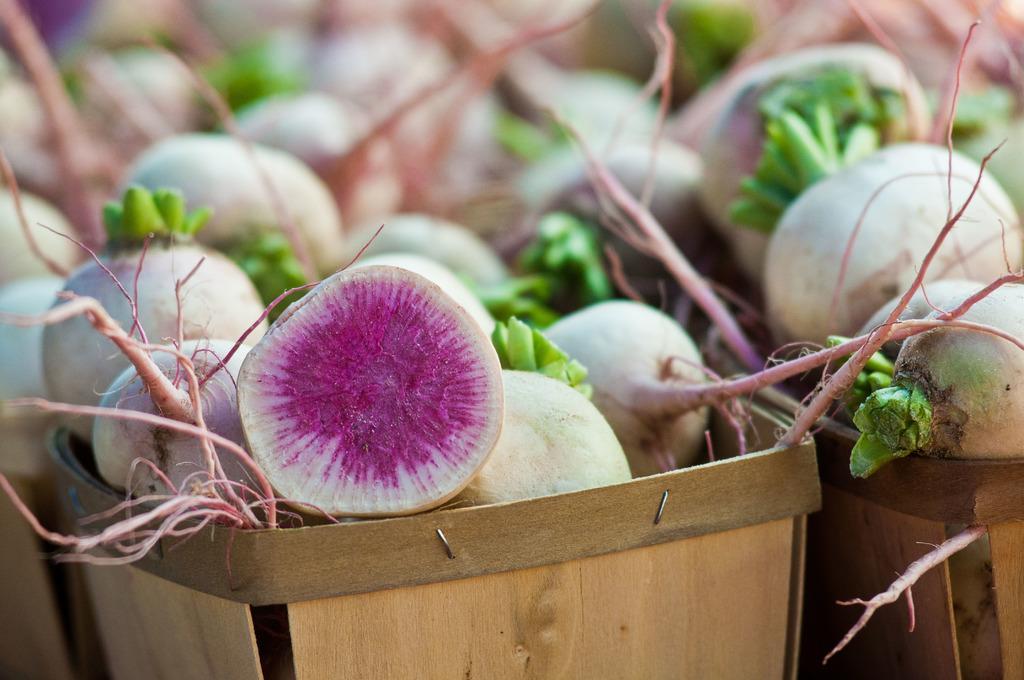How would you summarize this image in a sentence or two? In this picture, we see the baskets containing the fruits or the vegetables, which looks like a beetroot. This picture is blurred in the background. 